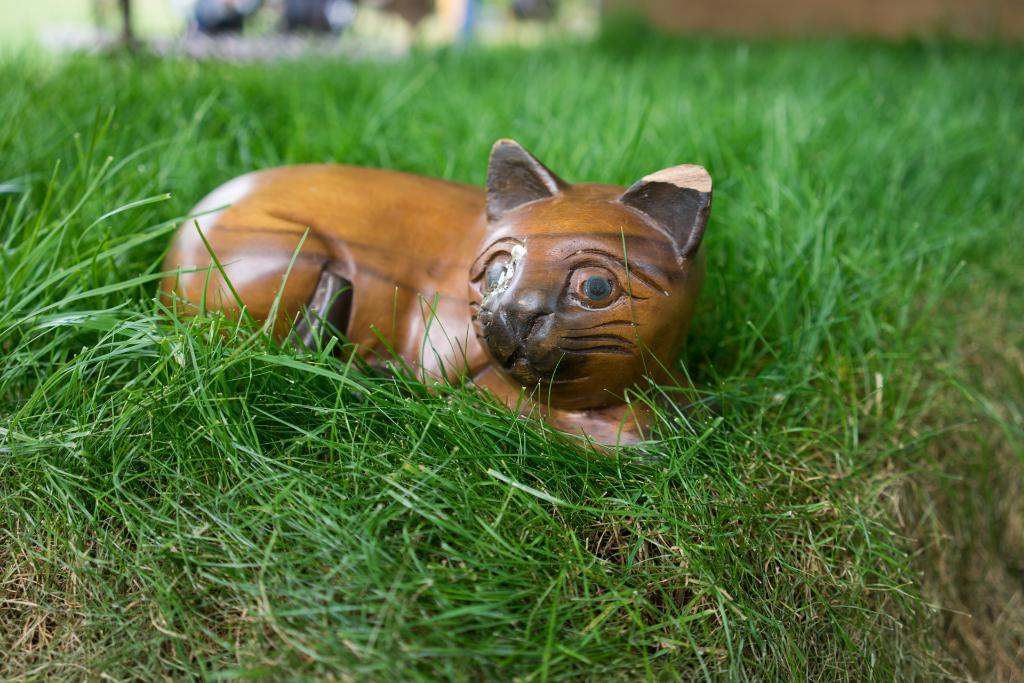What type of toy is in the image? There is a toy cat in the image. Where is the toy cat located? The toy cat is in the grass. What type of popcorn is the daughter using to sew the thread in the image? There is no popcorn, daughter, or thread present in the image; it only features a toy cat in the grass. 